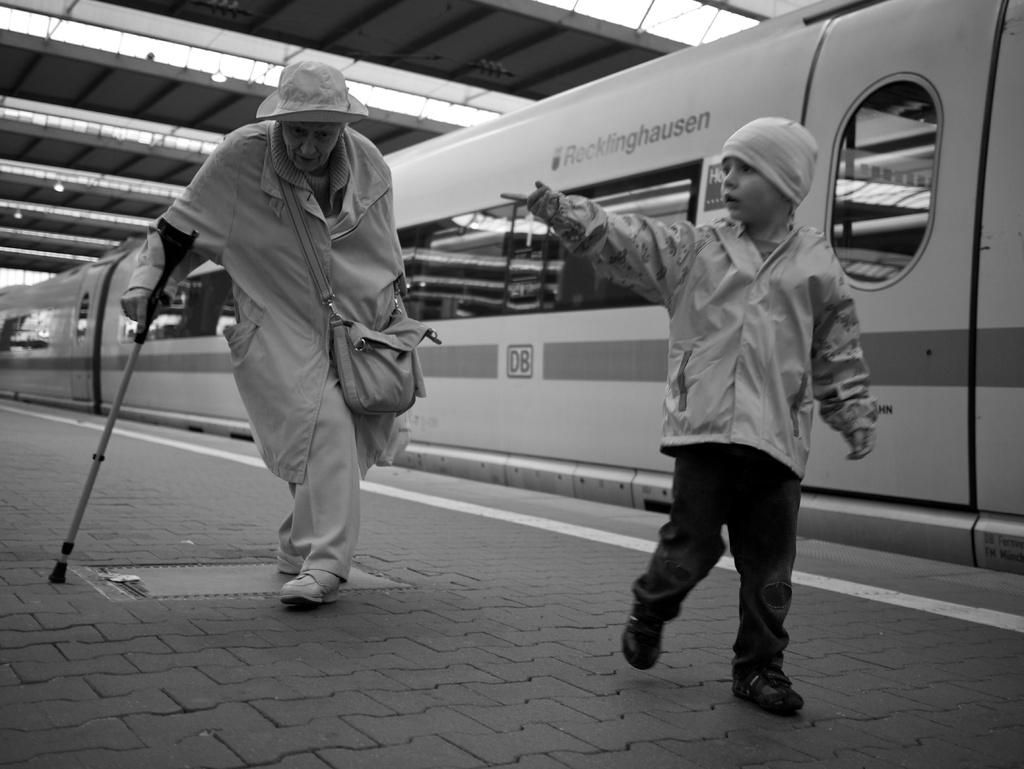<image>
Summarize the visual content of the image. two people with a subway with the number D8 on it 